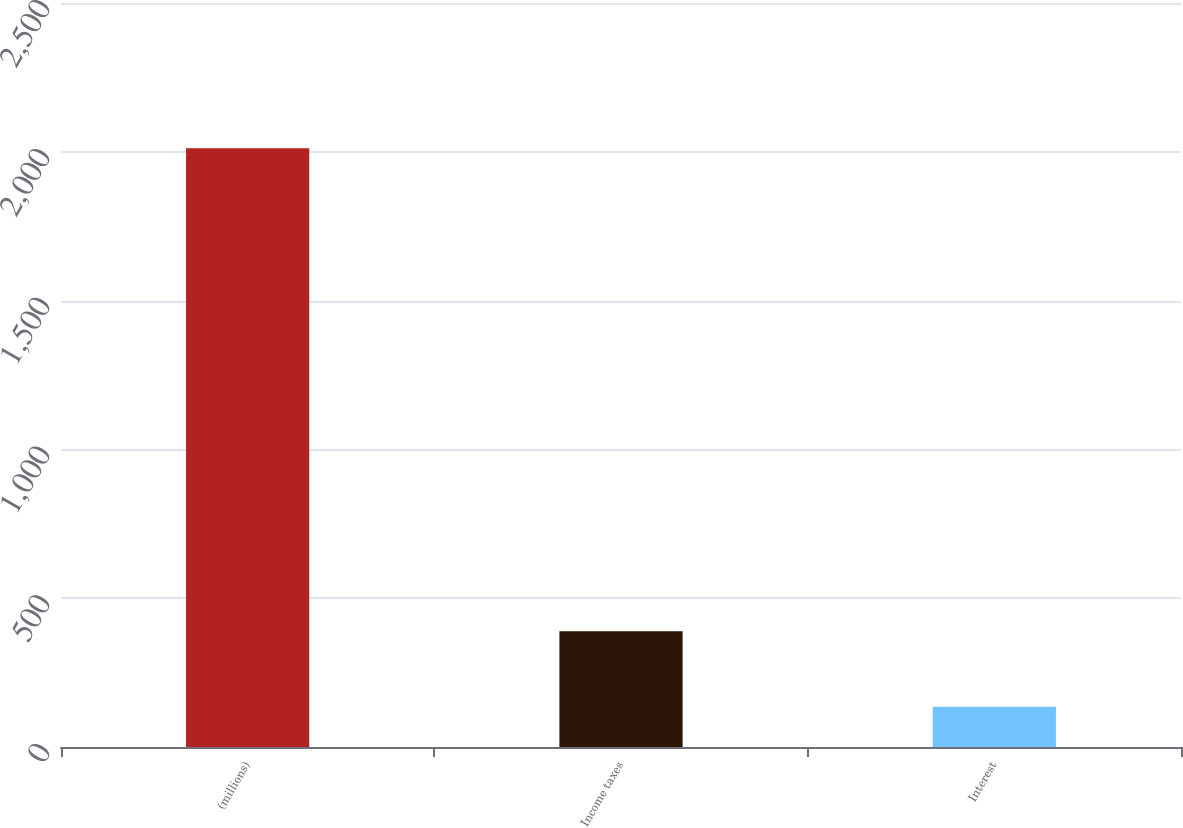Convert chart to OTSL. <chart><loc_0><loc_0><loc_500><loc_500><bar_chart><fcel>(millions)<fcel>Income taxes<fcel>Interest<nl><fcel>2012<fcel>389.1<fcel>135<nl></chart> 